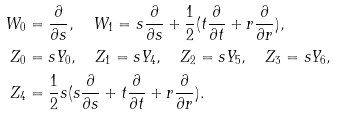<formula> <loc_0><loc_0><loc_500><loc_500>W _ { 0 } & = \frac { \partial } { \partial s } , \quad W _ { 1 } = s \frac { \partial } { \partial s } + \frac { 1 } { 2 } ( t \frac { \partial } { \partial t } + r \frac { \partial } { \partial r } ) , \\ Z _ { 0 } & = s Y _ { 0 } , \quad Z _ { 1 } = s Y _ { 4 } , \quad Z _ { 2 } = s Y _ { 5 } , \quad Z _ { 3 } = s Y _ { 6 } , \\ Z _ { 4 } & = \frac { 1 } { 2 } s ( s \frac { \partial } { \partial s } + t \frac { \partial } { \partial t } + r \frac { \partial } { \partial r } ) .</formula> 